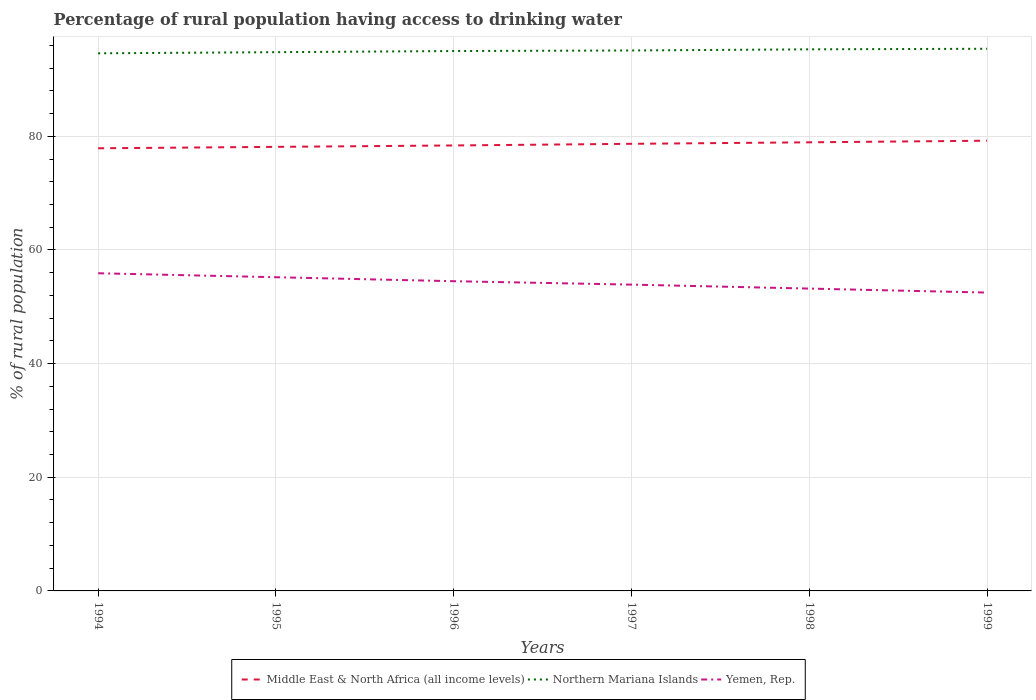How many different coloured lines are there?
Provide a short and direct response. 3. Across all years, what is the maximum percentage of rural population having access to drinking water in Northern Mariana Islands?
Keep it short and to the point. 94.6. In which year was the percentage of rural population having access to drinking water in Middle East & North Africa (all income levels) maximum?
Make the answer very short. 1994. What is the total percentage of rural population having access to drinking water in Middle East & North Africa (all income levels) in the graph?
Provide a succinct answer. -0.78. What is the difference between the highest and the second highest percentage of rural population having access to drinking water in Middle East & North Africa (all income levels)?
Ensure brevity in your answer.  1.33. Is the percentage of rural population having access to drinking water in Northern Mariana Islands strictly greater than the percentage of rural population having access to drinking water in Middle East & North Africa (all income levels) over the years?
Your answer should be compact. No. Does the graph contain any zero values?
Your answer should be compact. No. How are the legend labels stacked?
Offer a terse response. Horizontal. What is the title of the graph?
Your answer should be compact. Percentage of rural population having access to drinking water. What is the label or title of the X-axis?
Your response must be concise. Years. What is the label or title of the Y-axis?
Offer a terse response. % of rural population. What is the % of rural population of Middle East & North Africa (all income levels) in 1994?
Provide a short and direct response. 77.89. What is the % of rural population of Northern Mariana Islands in 1994?
Make the answer very short. 94.6. What is the % of rural population in Yemen, Rep. in 1994?
Make the answer very short. 55.9. What is the % of rural population in Middle East & North Africa (all income levels) in 1995?
Offer a terse response. 78.14. What is the % of rural population in Northern Mariana Islands in 1995?
Ensure brevity in your answer.  94.8. What is the % of rural population in Yemen, Rep. in 1995?
Offer a terse response. 55.2. What is the % of rural population of Middle East & North Africa (all income levels) in 1996?
Your answer should be very brief. 78.39. What is the % of rural population of Northern Mariana Islands in 1996?
Ensure brevity in your answer.  95. What is the % of rural population of Yemen, Rep. in 1996?
Keep it short and to the point. 54.5. What is the % of rural population of Middle East & North Africa (all income levels) in 1997?
Keep it short and to the point. 78.67. What is the % of rural population in Northern Mariana Islands in 1997?
Offer a very short reply. 95.1. What is the % of rural population of Yemen, Rep. in 1997?
Provide a short and direct response. 53.9. What is the % of rural population of Middle East & North Africa (all income levels) in 1998?
Give a very brief answer. 78.94. What is the % of rural population in Northern Mariana Islands in 1998?
Ensure brevity in your answer.  95.3. What is the % of rural population of Yemen, Rep. in 1998?
Offer a very short reply. 53.2. What is the % of rural population of Middle East & North Africa (all income levels) in 1999?
Make the answer very short. 79.22. What is the % of rural population of Northern Mariana Islands in 1999?
Give a very brief answer. 95.4. What is the % of rural population in Yemen, Rep. in 1999?
Keep it short and to the point. 52.5. Across all years, what is the maximum % of rural population of Middle East & North Africa (all income levels)?
Give a very brief answer. 79.22. Across all years, what is the maximum % of rural population in Northern Mariana Islands?
Provide a succinct answer. 95.4. Across all years, what is the maximum % of rural population of Yemen, Rep.?
Provide a short and direct response. 55.9. Across all years, what is the minimum % of rural population in Middle East & North Africa (all income levels)?
Provide a short and direct response. 77.89. Across all years, what is the minimum % of rural population of Northern Mariana Islands?
Provide a short and direct response. 94.6. Across all years, what is the minimum % of rural population in Yemen, Rep.?
Your response must be concise. 52.5. What is the total % of rural population of Middle East & North Africa (all income levels) in the graph?
Your response must be concise. 471.25. What is the total % of rural population of Northern Mariana Islands in the graph?
Offer a very short reply. 570.2. What is the total % of rural population in Yemen, Rep. in the graph?
Your answer should be very brief. 325.2. What is the difference between the % of rural population in Middle East & North Africa (all income levels) in 1994 and that in 1995?
Offer a very short reply. -0.25. What is the difference between the % of rural population in Northern Mariana Islands in 1994 and that in 1995?
Give a very brief answer. -0.2. What is the difference between the % of rural population of Yemen, Rep. in 1994 and that in 1995?
Give a very brief answer. 0.7. What is the difference between the % of rural population of Middle East & North Africa (all income levels) in 1994 and that in 1996?
Ensure brevity in your answer.  -0.49. What is the difference between the % of rural population of Middle East & North Africa (all income levels) in 1994 and that in 1997?
Make the answer very short. -0.78. What is the difference between the % of rural population of Middle East & North Africa (all income levels) in 1994 and that in 1998?
Keep it short and to the point. -1.05. What is the difference between the % of rural population in Middle East & North Africa (all income levels) in 1994 and that in 1999?
Give a very brief answer. -1.33. What is the difference between the % of rural population in Northern Mariana Islands in 1994 and that in 1999?
Provide a short and direct response. -0.8. What is the difference between the % of rural population in Yemen, Rep. in 1994 and that in 1999?
Your response must be concise. 3.4. What is the difference between the % of rural population in Middle East & North Africa (all income levels) in 1995 and that in 1996?
Your response must be concise. -0.25. What is the difference between the % of rural population in Middle East & North Africa (all income levels) in 1995 and that in 1997?
Make the answer very short. -0.54. What is the difference between the % of rural population of Yemen, Rep. in 1995 and that in 1997?
Offer a terse response. 1.3. What is the difference between the % of rural population of Middle East & North Africa (all income levels) in 1995 and that in 1998?
Your answer should be very brief. -0.8. What is the difference between the % of rural population in Yemen, Rep. in 1995 and that in 1998?
Keep it short and to the point. 2. What is the difference between the % of rural population in Middle East & North Africa (all income levels) in 1995 and that in 1999?
Offer a very short reply. -1.08. What is the difference between the % of rural population in Middle East & North Africa (all income levels) in 1996 and that in 1997?
Keep it short and to the point. -0.29. What is the difference between the % of rural population in Northern Mariana Islands in 1996 and that in 1997?
Your response must be concise. -0.1. What is the difference between the % of rural population in Yemen, Rep. in 1996 and that in 1997?
Offer a terse response. 0.6. What is the difference between the % of rural population of Middle East & North Africa (all income levels) in 1996 and that in 1998?
Your answer should be very brief. -0.55. What is the difference between the % of rural population of Middle East & North Africa (all income levels) in 1996 and that in 1999?
Provide a succinct answer. -0.84. What is the difference between the % of rural population of Yemen, Rep. in 1996 and that in 1999?
Your response must be concise. 2. What is the difference between the % of rural population of Middle East & North Africa (all income levels) in 1997 and that in 1998?
Your answer should be compact. -0.26. What is the difference between the % of rural population in Northern Mariana Islands in 1997 and that in 1998?
Ensure brevity in your answer.  -0.2. What is the difference between the % of rural population of Middle East & North Africa (all income levels) in 1997 and that in 1999?
Offer a very short reply. -0.55. What is the difference between the % of rural population of Northern Mariana Islands in 1997 and that in 1999?
Provide a succinct answer. -0.3. What is the difference between the % of rural population of Middle East & North Africa (all income levels) in 1998 and that in 1999?
Your answer should be compact. -0.28. What is the difference between the % of rural population in Northern Mariana Islands in 1998 and that in 1999?
Offer a terse response. -0.1. What is the difference between the % of rural population in Middle East & North Africa (all income levels) in 1994 and the % of rural population in Northern Mariana Islands in 1995?
Your answer should be very brief. -16.91. What is the difference between the % of rural population of Middle East & North Africa (all income levels) in 1994 and the % of rural population of Yemen, Rep. in 1995?
Keep it short and to the point. 22.69. What is the difference between the % of rural population in Northern Mariana Islands in 1994 and the % of rural population in Yemen, Rep. in 1995?
Ensure brevity in your answer.  39.4. What is the difference between the % of rural population of Middle East & North Africa (all income levels) in 1994 and the % of rural population of Northern Mariana Islands in 1996?
Make the answer very short. -17.11. What is the difference between the % of rural population of Middle East & North Africa (all income levels) in 1994 and the % of rural population of Yemen, Rep. in 1996?
Make the answer very short. 23.39. What is the difference between the % of rural population in Northern Mariana Islands in 1994 and the % of rural population in Yemen, Rep. in 1996?
Make the answer very short. 40.1. What is the difference between the % of rural population in Middle East & North Africa (all income levels) in 1994 and the % of rural population in Northern Mariana Islands in 1997?
Your response must be concise. -17.21. What is the difference between the % of rural population of Middle East & North Africa (all income levels) in 1994 and the % of rural population of Yemen, Rep. in 1997?
Provide a succinct answer. 23.99. What is the difference between the % of rural population of Northern Mariana Islands in 1994 and the % of rural population of Yemen, Rep. in 1997?
Offer a very short reply. 40.7. What is the difference between the % of rural population in Middle East & North Africa (all income levels) in 1994 and the % of rural population in Northern Mariana Islands in 1998?
Your response must be concise. -17.41. What is the difference between the % of rural population in Middle East & North Africa (all income levels) in 1994 and the % of rural population in Yemen, Rep. in 1998?
Give a very brief answer. 24.69. What is the difference between the % of rural population in Northern Mariana Islands in 1994 and the % of rural population in Yemen, Rep. in 1998?
Provide a short and direct response. 41.4. What is the difference between the % of rural population in Middle East & North Africa (all income levels) in 1994 and the % of rural population in Northern Mariana Islands in 1999?
Give a very brief answer. -17.51. What is the difference between the % of rural population of Middle East & North Africa (all income levels) in 1994 and the % of rural population of Yemen, Rep. in 1999?
Offer a very short reply. 25.39. What is the difference between the % of rural population in Northern Mariana Islands in 1994 and the % of rural population in Yemen, Rep. in 1999?
Make the answer very short. 42.1. What is the difference between the % of rural population in Middle East & North Africa (all income levels) in 1995 and the % of rural population in Northern Mariana Islands in 1996?
Keep it short and to the point. -16.86. What is the difference between the % of rural population in Middle East & North Africa (all income levels) in 1995 and the % of rural population in Yemen, Rep. in 1996?
Make the answer very short. 23.64. What is the difference between the % of rural population in Northern Mariana Islands in 1995 and the % of rural population in Yemen, Rep. in 1996?
Keep it short and to the point. 40.3. What is the difference between the % of rural population in Middle East & North Africa (all income levels) in 1995 and the % of rural population in Northern Mariana Islands in 1997?
Your answer should be very brief. -16.96. What is the difference between the % of rural population in Middle East & North Africa (all income levels) in 1995 and the % of rural population in Yemen, Rep. in 1997?
Provide a succinct answer. 24.24. What is the difference between the % of rural population in Northern Mariana Islands in 1995 and the % of rural population in Yemen, Rep. in 1997?
Offer a terse response. 40.9. What is the difference between the % of rural population of Middle East & North Africa (all income levels) in 1995 and the % of rural population of Northern Mariana Islands in 1998?
Make the answer very short. -17.16. What is the difference between the % of rural population of Middle East & North Africa (all income levels) in 1995 and the % of rural population of Yemen, Rep. in 1998?
Your answer should be very brief. 24.94. What is the difference between the % of rural population in Northern Mariana Islands in 1995 and the % of rural population in Yemen, Rep. in 1998?
Offer a terse response. 41.6. What is the difference between the % of rural population in Middle East & North Africa (all income levels) in 1995 and the % of rural population in Northern Mariana Islands in 1999?
Ensure brevity in your answer.  -17.26. What is the difference between the % of rural population of Middle East & North Africa (all income levels) in 1995 and the % of rural population of Yemen, Rep. in 1999?
Provide a short and direct response. 25.64. What is the difference between the % of rural population in Northern Mariana Islands in 1995 and the % of rural population in Yemen, Rep. in 1999?
Provide a succinct answer. 42.3. What is the difference between the % of rural population of Middle East & North Africa (all income levels) in 1996 and the % of rural population of Northern Mariana Islands in 1997?
Your response must be concise. -16.71. What is the difference between the % of rural population of Middle East & North Africa (all income levels) in 1996 and the % of rural population of Yemen, Rep. in 1997?
Ensure brevity in your answer.  24.49. What is the difference between the % of rural population of Northern Mariana Islands in 1996 and the % of rural population of Yemen, Rep. in 1997?
Provide a succinct answer. 41.1. What is the difference between the % of rural population of Middle East & North Africa (all income levels) in 1996 and the % of rural population of Northern Mariana Islands in 1998?
Your response must be concise. -16.91. What is the difference between the % of rural population in Middle East & North Africa (all income levels) in 1996 and the % of rural population in Yemen, Rep. in 1998?
Provide a succinct answer. 25.19. What is the difference between the % of rural population in Northern Mariana Islands in 1996 and the % of rural population in Yemen, Rep. in 1998?
Offer a very short reply. 41.8. What is the difference between the % of rural population in Middle East & North Africa (all income levels) in 1996 and the % of rural population in Northern Mariana Islands in 1999?
Make the answer very short. -17.01. What is the difference between the % of rural population of Middle East & North Africa (all income levels) in 1996 and the % of rural population of Yemen, Rep. in 1999?
Your answer should be compact. 25.89. What is the difference between the % of rural population of Northern Mariana Islands in 1996 and the % of rural population of Yemen, Rep. in 1999?
Offer a terse response. 42.5. What is the difference between the % of rural population of Middle East & North Africa (all income levels) in 1997 and the % of rural population of Northern Mariana Islands in 1998?
Make the answer very short. -16.63. What is the difference between the % of rural population of Middle East & North Africa (all income levels) in 1997 and the % of rural population of Yemen, Rep. in 1998?
Give a very brief answer. 25.47. What is the difference between the % of rural population of Northern Mariana Islands in 1997 and the % of rural population of Yemen, Rep. in 1998?
Ensure brevity in your answer.  41.9. What is the difference between the % of rural population in Middle East & North Africa (all income levels) in 1997 and the % of rural population in Northern Mariana Islands in 1999?
Your answer should be very brief. -16.73. What is the difference between the % of rural population of Middle East & North Africa (all income levels) in 1997 and the % of rural population of Yemen, Rep. in 1999?
Offer a terse response. 26.17. What is the difference between the % of rural population in Northern Mariana Islands in 1997 and the % of rural population in Yemen, Rep. in 1999?
Keep it short and to the point. 42.6. What is the difference between the % of rural population of Middle East & North Africa (all income levels) in 1998 and the % of rural population of Northern Mariana Islands in 1999?
Make the answer very short. -16.46. What is the difference between the % of rural population of Middle East & North Africa (all income levels) in 1998 and the % of rural population of Yemen, Rep. in 1999?
Offer a very short reply. 26.44. What is the difference between the % of rural population in Northern Mariana Islands in 1998 and the % of rural population in Yemen, Rep. in 1999?
Offer a very short reply. 42.8. What is the average % of rural population of Middle East & North Africa (all income levels) per year?
Ensure brevity in your answer.  78.54. What is the average % of rural population in Northern Mariana Islands per year?
Give a very brief answer. 95.03. What is the average % of rural population of Yemen, Rep. per year?
Keep it short and to the point. 54.2. In the year 1994, what is the difference between the % of rural population of Middle East & North Africa (all income levels) and % of rural population of Northern Mariana Islands?
Ensure brevity in your answer.  -16.71. In the year 1994, what is the difference between the % of rural population in Middle East & North Africa (all income levels) and % of rural population in Yemen, Rep.?
Provide a short and direct response. 21.99. In the year 1994, what is the difference between the % of rural population of Northern Mariana Islands and % of rural population of Yemen, Rep.?
Your answer should be compact. 38.7. In the year 1995, what is the difference between the % of rural population in Middle East & North Africa (all income levels) and % of rural population in Northern Mariana Islands?
Your response must be concise. -16.66. In the year 1995, what is the difference between the % of rural population of Middle East & North Africa (all income levels) and % of rural population of Yemen, Rep.?
Provide a succinct answer. 22.94. In the year 1995, what is the difference between the % of rural population in Northern Mariana Islands and % of rural population in Yemen, Rep.?
Provide a succinct answer. 39.6. In the year 1996, what is the difference between the % of rural population in Middle East & North Africa (all income levels) and % of rural population in Northern Mariana Islands?
Make the answer very short. -16.61. In the year 1996, what is the difference between the % of rural population of Middle East & North Africa (all income levels) and % of rural population of Yemen, Rep.?
Ensure brevity in your answer.  23.89. In the year 1996, what is the difference between the % of rural population of Northern Mariana Islands and % of rural population of Yemen, Rep.?
Ensure brevity in your answer.  40.5. In the year 1997, what is the difference between the % of rural population of Middle East & North Africa (all income levels) and % of rural population of Northern Mariana Islands?
Offer a terse response. -16.43. In the year 1997, what is the difference between the % of rural population of Middle East & North Africa (all income levels) and % of rural population of Yemen, Rep.?
Offer a very short reply. 24.77. In the year 1997, what is the difference between the % of rural population of Northern Mariana Islands and % of rural population of Yemen, Rep.?
Offer a very short reply. 41.2. In the year 1998, what is the difference between the % of rural population in Middle East & North Africa (all income levels) and % of rural population in Northern Mariana Islands?
Offer a very short reply. -16.36. In the year 1998, what is the difference between the % of rural population of Middle East & North Africa (all income levels) and % of rural population of Yemen, Rep.?
Offer a very short reply. 25.74. In the year 1998, what is the difference between the % of rural population of Northern Mariana Islands and % of rural population of Yemen, Rep.?
Give a very brief answer. 42.1. In the year 1999, what is the difference between the % of rural population of Middle East & North Africa (all income levels) and % of rural population of Northern Mariana Islands?
Offer a very short reply. -16.18. In the year 1999, what is the difference between the % of rural population of Middle East & North Africa (all income levels) and % of rural population of Yemen, Rep.?
Offer a very short reply. 26.72. In the year 1999, what is the difference between the % of rural population in Northern Mariana Islands and % of rural population in Yemen, Rep.?
Ensure brevity in your answer.  42.9. What is the ratio of the % of rural population in Middle East & North Africa (all income levels) in 1994 to that in 1995?
Keep it short and to the point. 1. What is the ratio of the % of rural population of Yemen, Rep. in 1994 to that in 1995?
Your answer should be compact. 1.01. What is the ratio of the % of rural population in Northern Mariana Islands in 1994 to that in 1996?
Give a very brief answer. 1. What is the ratio of the % of rural population in Yemen, Rep. in 1994 to that in 1996?
Make the answer very short. 1.03. What is the ratio of the % of rural population of Northern Mariana Islands in 1994 to that in 1997?
Keep it short and to the point. 0.99. What is the ratio of the % of rural population of Yemen, Rep. in 1994 to that in 1997?
Keep it short and to the point. 1.04. What is the ratio of the % of rural population in Middle East & North Africa (all income levels) in 1994 to that in 1998?
Your answer should be very brief. 0.99. What is the ratio of the % of rural population in Yemen, Rep. in 1994 to that in 1998?
Your answer should be compact. 1.05. What is the ratio of the % of rural population of Middle East & North Africa (all income levels) in 1994 to that in 1999?
Ensure brevity in your answer.  0.98. What is the ratio of the % of rural population of Yemen, Rep. in 1994 to that in 1999?
Offer a terse response. 1.06. What is the ratio of the % of rural population of Middle East & North Africa (all income levels) in 1995 to that in 1996?
Provide a succinct answer. 1. What is the ratio of the % of rural population in Yemen, Rep. in 1995 to that in 1996?
Your answer should be very brief. 1.01. What is the ratio of the % of rural population of Yemen, Rep. in 1995 to that in 1997?
Your answer should be very brief. 1.02. What is the ratio of the % of rural population in Northern Mariana Islands in 1995 to that in 1998?
Ensure brevity in your answer.  0.99. What is the ratio of the % of rural population of Yemen, Rep. in 1995 to that in 1998?
Keep it short and to the point. 1.04. What is the ratio of the % of rural population of Middle East & North Africa (all income levels) in 1995 to that in 1999?
Your answer should be compact. 0.99. What is the ratio of the % of rural population of Yemen, Rep. in 1995 to that in 1999?
Offer a very short reply. 1.05. What is the ratio of the % of rural population in Middle East & North Africa (all income levels) in 1996 to that in 1997?
Give a very brief answer. 1. What is the ratio of the % of rural population in Northern Mariana Islands in 1996 to that in 1997?
Keep it short and to the point. 1. What is the ratio of the % of rural population of Yemen, Rep. in 1996 to that in 1997?
Ensure brevity in your answer.  1.01. What is the ratio of the % of rural population of Middle East & North Africa (all income levels) in 1996 to that in 1998?
Give a very brief answer. 0.99. What is the ratio of the % of rural population of Yemen, Rep. in 1996 to that in 1998?
Ensure brevity in your answer.  1.02. What is the ratio of the % of rural population of Middle East & North Africa (all income levels) in 1996 to that in 1999?
Your response must be concise. 0.99. What is the ratio of the % of rural population in Yemen, Rep. in 1996 to that in 1999?
Give a very brief answer. 1.04. What is the ratio of the % of rural population in Northern Mariana Islands in 1997 to that in 1998?
Give a very brief answer. 1. What is the ratio of the % of rural population in Yemen, Rep. in 1997 to that in 1998?
Keep it short and to the point. 1.01. What is the ratio of the % of rural population in Middle East & North Africa (all income levels) in 1997 to that in 1999?
Your answer should be very brief. 0.99. What is the ratio of the % of rural population in Yemen, Rep. in 1997 to that in 1999?
Make the answer very short. 1.03. What is the ratio of the % of rural population in Middle East & North Africa (all income levels) in 1998 to that in 1999?
Provide a short and direct response. 1. What is the ratio of the % of rural population of Northern Mariana Islands in 1998 to that in 1999?
Offer a very short reply. 1. What is the ratio of the % of rural population in Yemen, Rep. in 1998 to that in 1999?
Offer a very short reply. 1.01. What is the difference between the highest and the second highest % of rural population in Middle East & North Africa (all income levels)?
Make the answer very short. 0.28. What is the difference between the highest and the second highest % of rural population of Yemen, Rep.?
Keep it short and to the point. 0.7. What is the difference between the highest and the lowest % of rural population in Middle East & North Africa (all income levels)?
Your answer should be compact. 1.33. What is the difference between the highest and the lowest % of rural population of Northern Mariana Islands?
Your answer should be compact. 0.8. What is the difference between the highest and the lowest % of rural population of Yemen, Rep.?
Ensure brevity in your answer.  3.4. 